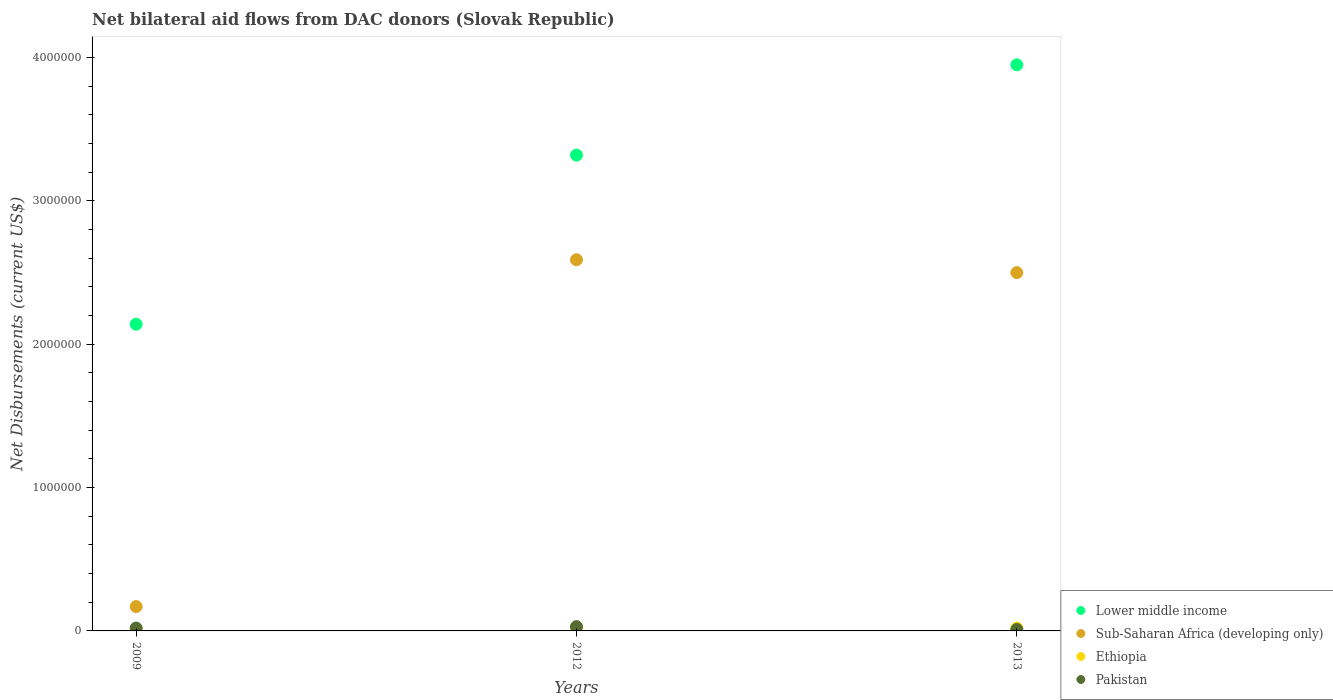Is the number of dotlines equal to the number of legend labels?
Your answer should be very brief. Yes. Across all years, what is the minimum net bilateral aid flows in Sub-Saharan Africa (developing only)?
Your answer should be very brief. 1.70e+05. In which year was the net bilateral aid flows in Pakistan maximum?
Provide a short and direct response. 2012. In which year was the net bilateral aid flows in Pakistan minimum?
Offer a terse response. 2013. What is the total net bilateral aid flows in Pakistan in the graph?
Provide a short and direct response. 6.00e+04. What is the average net bilateral aid flows in Lower middle income per year?
Offer a very short reply. 3.14e+06. In how many years, is the net bilateral aid flows in Lower middle income greater than 3800000 US$?
Offer a very short reply. 1. Is the net bilateral aid flows in Lower middle income in 2009 less than that in 2013?
Provide a succinct answer. Yes. Is the difference between the net bilateral aid flows in Pakistan in 2012 and 2013 greater than the difference between the net bilateral aid flows in Sub-Saharan Africa (developing only) in 2012 and 2013?
Provide a short and direct response. No. Is the sum of the net bilateral aid flows in Ethiopia in 2009 and 2012 greater than the maximum net bilateral aid flows in Lower middle income across all years?
Provide a short and direct response. No. Does the net bilateral aid flows in Ethiopia monotonically increase over the years?
Your answer should be compact. No. Is the net bilateral aid flows in Pakistan strictly greater than the net bilateral aid flows in Lower middle income over the years?
Offer a very short reply. No. How many years are there in the graph?
Make the answer very short. 3. Are the values on the major ticks of Y-axis written in scientific E-notation?
Provide a succinct answer. No. Where does the legend appear in the graph?
Your response must be concise. Bottom right. How many legend labels are there?
Your answer should be very brief. 4. What is the title of the graph?
Your answer should be very brief. Net bilateral aid flows from DAC donors (Slovak Republic). Does "Australia" appear as one of the legend labels in the graph?
Provide a short and direct response. No. What is the label or title of the X-axis?
Offer a very short reply. Years. What is the label or title of the Y-axis?
Offer a terse response. Net Disbursements (current US$). What is the Net Disbursements (current US$) of Lower middle income in 2009?
Offer a very short reply. 2.14e+06. What is the Net Disbursements (current US$) of Sub-Saharan Africa (developing only) in 2009?
Your answer should be compact. 1.70e+05. What is the Net Disbursements (current US$) of Ethiopia in 2009?
Give a very brief answer. 10000. What is the Net Disbursements (current US$) of Lower middle income in 2012?
Keep it short and to the point. 3.32e+06. What is the Net Disbursements (current US$) of Sub-Saharan Africa (developing only) in 2012?
Keep it short and to the point. 2.59e+06. What is the Net Disbursements (current US$) in Ethiopia in 2012?
Make the answer very short. 2.00e+04. What is the Net Disbursements (current US$) in Pakistan in 2012?
Your answer should be compact. 3.00e+04. What is the Net Disbursements (current US$) in Lower middle income in 2013?
Make the answer very short. 3.95e+06. What is the Net Disbursements (current US$) in Sub-Saharan Africa (developing only) in 2013?
Give a very brief answer. 2.50e+06. What is the Net Disbursements (current US$) of Ethiopia in 2013?
Your answer should be very brief. 2.00e+04. What is the Net Disbursements (current US$) of Pakistan in 2013?
Provide a succinct answer. 10000. Across all years, what is the maximum Net Disbursements (current US$) in Lower middle income?
Offer a very short reply. 3.95e+06. Across all years, what is the maximum Net Disbursements (current US$) of Sub-Saharan Africa (developing only)?
Provide a short and direct response. 2.59e+06. Across all years, what is the minimum Net Disbursements (current US$) of Lower middle income?
Offer a very short reply. 2.14e+06. Across all years, what is the minimum Net Disbursements (current US$) in Sub-Saharan Africa (developing only)?
Offer a very short reply. 1.70e+05. Across all years, what is the minimum Net Disbursements (current US$) of Ethiopia?
Give a very brief answer. 10000. What is the total Net Disbursements (current US$) of Lower middle income in the graph?
Give a very brief answer. 9.41e+06. What is the total Net Disbursements (current US$) of Sub-Saharan Africa (developing only) in the graph?
Make the answer very short. 5.26e+06. What is the total Net Disbursements (current US$) in Pakistan in the graph?
Offer a terse response. 6.00e+04. What is the difference between the Net Disbursements (current US$) of Lower middle income in 2009 and that in 2012?
Provide a succinct answer. -1.18e+06. What is the difference between the Net Disbursements (current US$) of Sub-Saharan Africa (developing only) in 2009 and that in 2012?
Provide a short and direct response. -2.42e+06. What is the difference between the Net Disbursements (current US$) of Lower middle income in 2009 and that in 2013?
Provide a short and direct response. -1.81e+06. What is the difference between the Net Disbursements (current US$) in Sub-Saharan Africa (developing only) in 2009 and that in 2013?
Keep it short and to the point. -2.33e+06. What is the difference between the Net Disbursements (current US$) of Lower middle income in 2012 and that in 2013?
Provide a succinct answer. -6.30e+05. What is the difference between the Net Disbursements (current US$) of Pakistan in 2012 and that in 2013?
Your answer should be very brief. 2.00e+04. What is the difference between the Net Disbursements (current US$) of Lower middle income in 2009 and the Net Disbursements (current US$) of Sub-Saharan Africa (developing only) in 2012?
Ensure brevity in your answer.  -4.50e+05. What is the difference between the Net Disbursements (current US$) in Lower middle income in 2009 and the Net Disbursements (current US$) in Ethiopia in 2012?
Make the answer very short. 2.12e+06. What is the difference between the Net Disbursements (current US$) in Lower middle income in 2009 and the Net Disbursements (current US$) in Pakistan in 2012?
Offer a very short reply. 2.11e+06. What is the difference between the Net Disbursements (current US$) in Sub-Saharan Africa (developing only) in 2009 and the Net Disbursements (current US$) in Ethiopia in 2012?
Your response must be concise. 1.50e+05. What is the difference between the Net Disbursements (current US$) in Lower middle income in 2009 and the Net Disbursements (current US$) in Sub-Saharan Africa (developing only) in 2013?
Provide a succinct answer. -3.60e+05. What is the difference between the Net Disbursements (current US$) of Lower middle income in 2009 and the Net Disbursements (current US$) of Ethiopia in 2013?
Ensure brevity in your answer.  2.12e+06. What is the difference between the Net Disbursements (current US$) of Lower middle income in 2009 and the Net Disbursements (current US$) of Pakistan in 2013?
Provide a short and direct response. 2.13e+06. What is the difference between the Net Disbursements (current US$) in Sub-Saharan Africa (developing only) in 2009 and the Net Disbursements (current US$) in Ethiopia in 2013?
Keep it short and to the point. 1.50e+05. What is the difference between the Net Disbursements (current US$) in Sub-Saharan Africa (developing only) in 2009 and the Net Disbursements (current US$) in Pakistan in 2013?
Provide a succinct answer. 1.60e+05. What is the difference between the Net Disbursements (current US$) in Ethiopia in 2009 and the Net Disbursements (current US$) in Pakistan in 2013?
Keep it short and to the point. 0. What is the difference between the Net Disbursements (current US$) in Lower middle income in 2012 and the Net Disbursements (current US$) in Sub-Saharan Africa (developing only) in 2013?
Offer a terse response. 8.20e+05. What is the difference between the Net Disbursements (current US$) of Lower middle income in 2012 and the Net Disbursements (current US$) of Ethiopia in 2013?
Give a very brief answer. 3.30e+06. What is the difference between the Net Disbursements (current US$) in Lower middle income in 2012 and the Net Disbursements (current US$) in Pakistan in 2013?
Provide a short and direct response. 3.31e+06. What is the difference between the Net Disbursements (current US$) in Sub-Saharan Africa (developing only) in 2012 and the Net Disbursements (current US$) in Ethiopia in 2013?
Make the answer very short. 2.57e+06. What is the difference between the Net Disbursements (current US$) in Sub-Saharan Africa (developing only) in 2012 and the Net Disbursements (current US$) in Pakistan in 2013?
Make the answer very short. 2.58e+06. What is the difference between the Net Disbursements (current US$) of Ethiopia in 2012 and the Net Disbursements (current US$) of Pakistan in 2013?
Keep it short and to the point. 10000. What is the average Net Disbursements (current US$) of Lower middle income per year?
Your answer should be compact. 3.14e+06. What is the average Net Disbursements (current US$) in Sub-Saharan Africa (developing only) per year?
Your response must be concise. 1.75e+06. What is the average Net Disbursements (current US$) in Ethiopia per year?
Make the answer very short. 1.67e+04. What is the average Net Disbursements (current US$) in Pakistan per year?
Offer a very short reply. 2.00e+04. In the year 2009, what is the difference between the Net Disbursements (current US$) of Lower middle income and Net Disbursements (current US$) of Sub-Saharan Africa (developing only)?
Offer a very short reply. 1.97e+06. In the year 2009, what is the difference between the Net Disbursements (current US$) of Lower middle income and Net Disbursements (current US$) of Ethiopia?
Keep it short and to the point. 2.13e+06. In the year 2009, what is the difference between the Net Disbursements (current US$) of Lower middle income and Net Disbursements (current US$) of Pakistan?
Offer a terse response. 2.12e+06. In the year 2009, what is the difference between the Net Disbursements (current US$) of Ethiopia and Net Disbursements (current US$) of Pakistan?
Provide a short and direct response. -10000. In the year 2012, what is the difference between the Net Disbursements (current US$) of Lower middle income and Net Disbursements (current US$) of Sub-Saharan Africa (developing only)?
Your answer should be very brief. 7.30e+05. In the year 2012, what is the difference between the Net Disbursements (current US$) of Lower middle income and Net Disbursements (current US$) of Ethiopia?
Your answer should be very brief. 3.30e+06. In the year 2012, what is the difference between the Net Disbursements (current US$) of Lower middle income and Net Disbursements (current US$) of Pakistan?
Your answer should be compact. 3.29e+06. In the year 2012, what is the difference between the Net Disbursements (current US$) in Sub-Saharan Africa (developing only) and Net Disbursements (current US$) in Ethiopia?
Provide a short and direct response. 2.57e+06. In the year 2012, what is the difference between the Net Disbursements (current US$) of Sub-Saharan Africa (developing only) and Net Disbursements (current US$) of Pakistan?
Offer a very short reply. 2.56e+06. In the year 2013, what is the difference between the Net Disbursements (current US$) in Lower middle income and Net Disbursements (current US$) in Sub-Saharan Africa (developing only)?
Provide a short and direct response. 1.45e+06. In the year 2013, what is the difference between the Net Disbursements (current US$) of Lower middle income and Net Disbursements (current US$) of Ethiopia?
Your answer should be very brief. 3.93e+06. In the year 2013, what is the difference between the Net Disbursements (current US$) of Lower middle income and Net Disbursements (current US$) of Pakistan?
Your response must be concise. 3.94e+06. In the year 2013, what is the difference between the Net Disbursements (current US$) in Sub-Saharan Africa (developing only) and Net Disbursements (current US$) in Ethiopia?
Your response must be concise. 2.48e+06. In the year 2013, what is the difference between the Net Disbursements (current US$) in Sub-Saharan Africa (developing only) and Net Disbursements (current US$) in Pakistan?
Offer a terse response. 2.49e+06. In the year 2013, what is the difference between the Net Disbursements (current US$) in Ethiopia and Net Disbursements (current US$) in Pakistan?
Provide a succinct answer. 10000. What is the ratio of the Net Disbursements (current US$) of Lower middle income in 2009 to that in 2012?
Ensure brevity in your answer.  0.64. What is the ratio of the Net Disbursements (current US$) in Sub-Saharan Africa (developing only) in 2009 to that in 2012?
Your answer should be very brief. 0.07. What is the ratio of the Net Disbursements (current US$) in Pakistan in 2009 to that in 2012?
Offer a very short reply. 0.67. What is the ratio of the Net Disbursements (current US$) of Lower middle income in 2009 to that in 2013?
Provide a short and direct response. 0.54. What is the ratio of the Net Disbursements (current US$) in Sub-Saharan Africa (developing only) in 2009 to that in 2013?
Provide a short and direct response. 0.07. What is the ratio of the Net Disbursements (current US$) in Lower middle income in 2012 to that in 2013?
Offer a terse response. 0.84. What is the ratio of the Net Disbursements (current US$) of Sub-Saharan Africa (developing only) in 2012 to that in 2013?
Your answer should be compact. 1.04. What is the ratio of the Net Disbursements (current US$) of Ethiopia in 2012 to that in 2013?
Ensure brevity in your answer.  1. What is the ratio of the Net Disbursements (current US$) in Pakistan in 2012 to that in 2013?
Your answer should be compact. 3. What is the difference between the highest and the second highest Net Disbursements (current US$) in Lower middle income?
Give a very brief answer. 6.30e+05. What is the difference between the highest and the second highest Net Disbursements (current US$) in Sub-Saharan Africa (developing only)?
Give a very brief answer. 9.00e+04. What is the difference between the highest and the lowest Net Disbursements (current US$) in Lower middle income?
Give a very brief answer. 1.81e+06. What is the difference between the highest and the lowest Net Disbursements (current US$) in Sub-Saharan Africa (developing only)?
Your answer should be very brief. 2.42e+06. What is the difference between the highest and the lowest Net Disbursements (current US$) in Pakistan?
Provide a succinct answer. 2.00e+04. 